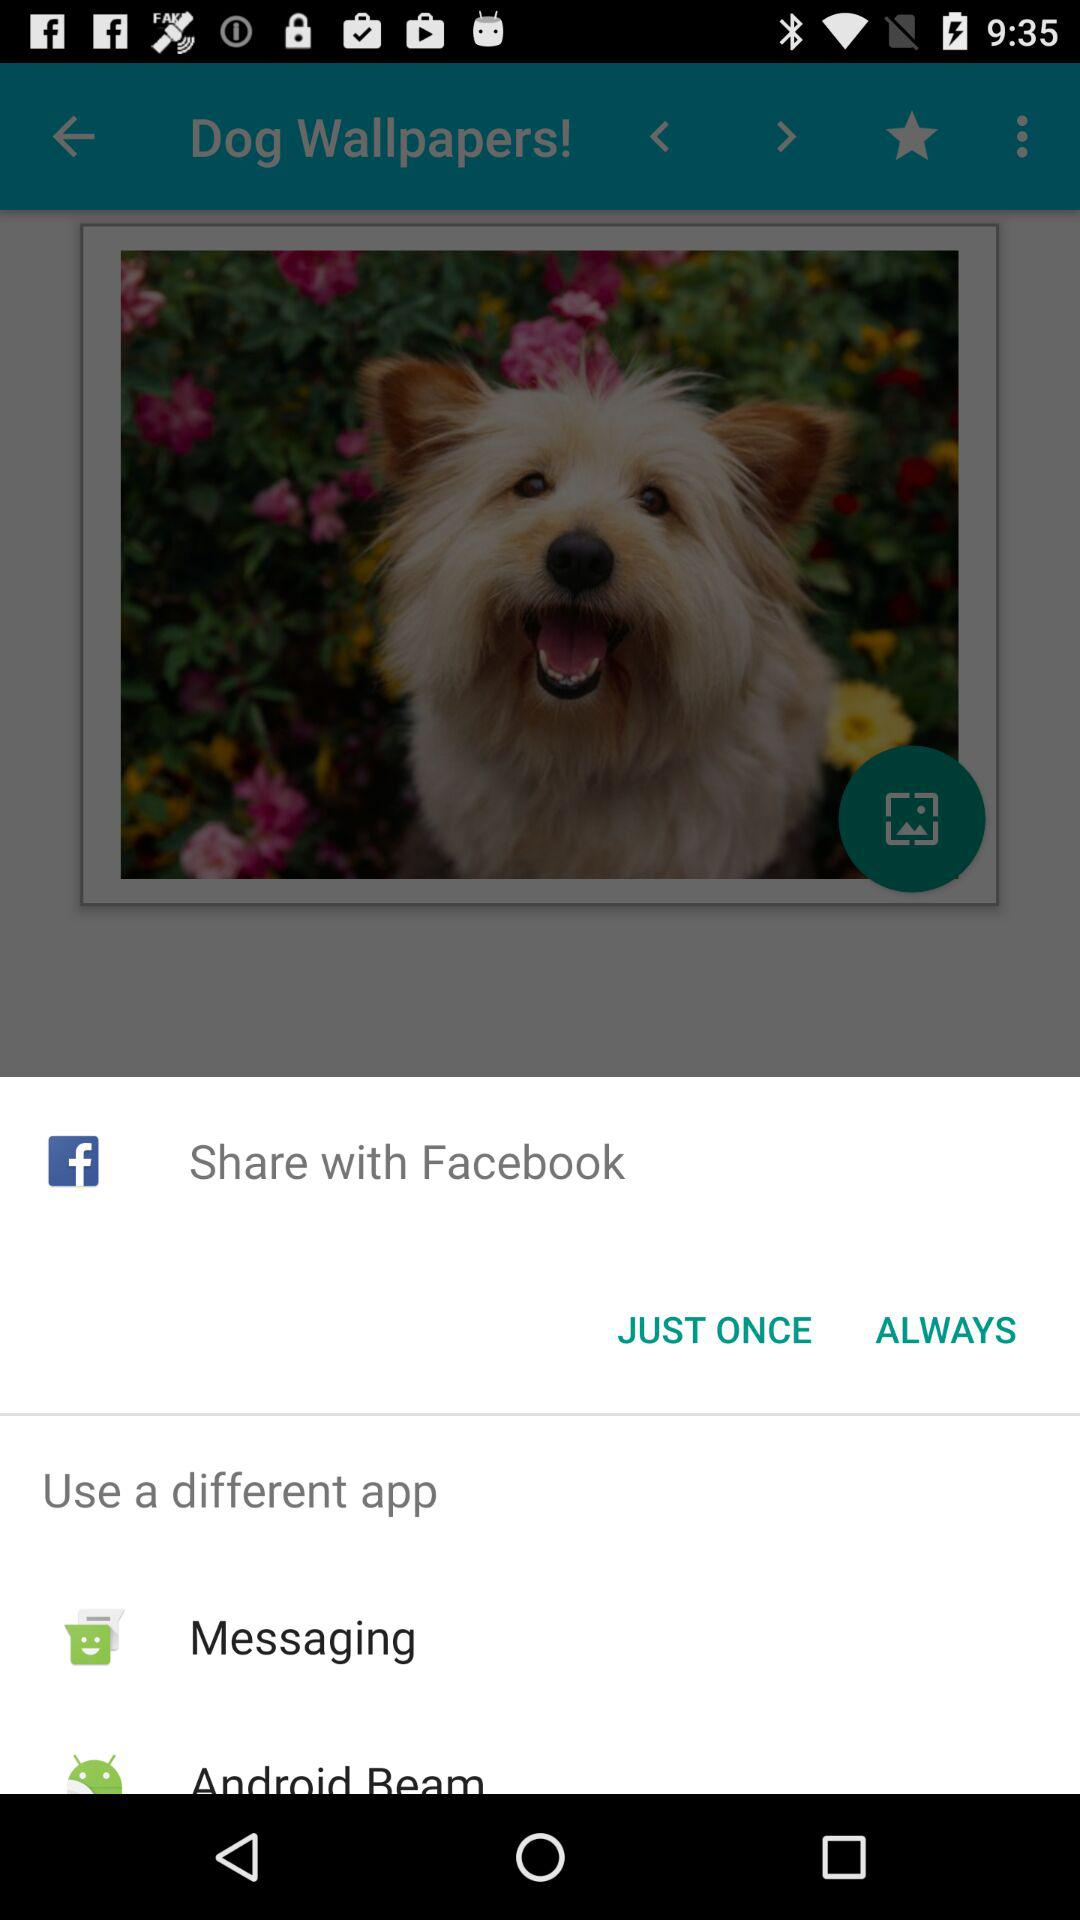Which applications can be used to share? The applications "Facebook", "Messaging" and "Android Beam" can be used to share. 